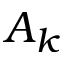<formula> <loc_0><loc_0><loc_500><loc_500>A _ { k }</formula> 